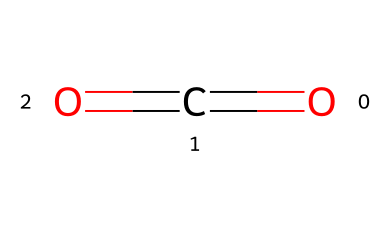What is the molecular formula of this refrigerant? The SMILES representation "O=C=O" indicates that the molecule consists of one carbon atom (C) and two oxygen atoms (O). Together, this forms the molecular formula CO2.
Answer: CO2 How many double bonds are present in the structure? The SMILES notation shows two "=" signs, indicating two double bonds between the carbon and each of the oxygen atoms. Therefore, there are two double bonds present in the structure.
Answer: 2 What type of intermolecular forces are primarily present in this compound? R-744 (CO2) has nonpolar characteristics due to its symmetrical linear arrangement of atoms. Therefore, the primary intermolecular forces are Van der Waals (dispersion) forces.
Answer: Van der Waals Is R-744 a greenhouse gas? Carbon dioxide (CO2) is classified as a greenhouse gas due to its ability to trap heat in the atmosphere.
Answer: Yes What are the primary applications of R-744 as a refrigerant? R-744 is commonly used in commercial refrigeration systems, particularly in supermarkets and chilled warehouses.
Answer: Commercial refrigeration How does the molecular arrangement affect its refrigerant properties? The linear molecular arrangement of R-744 allows for efficient heat transfer, making it effective in refrigeration cycles, while also being environmentally friendly compared to other refrigerants.
Answer: Efficient heat transfer 